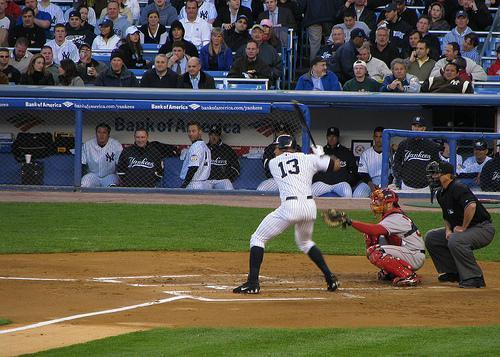How many people are on the field in the picture?
Give a very brief answer. 3. 